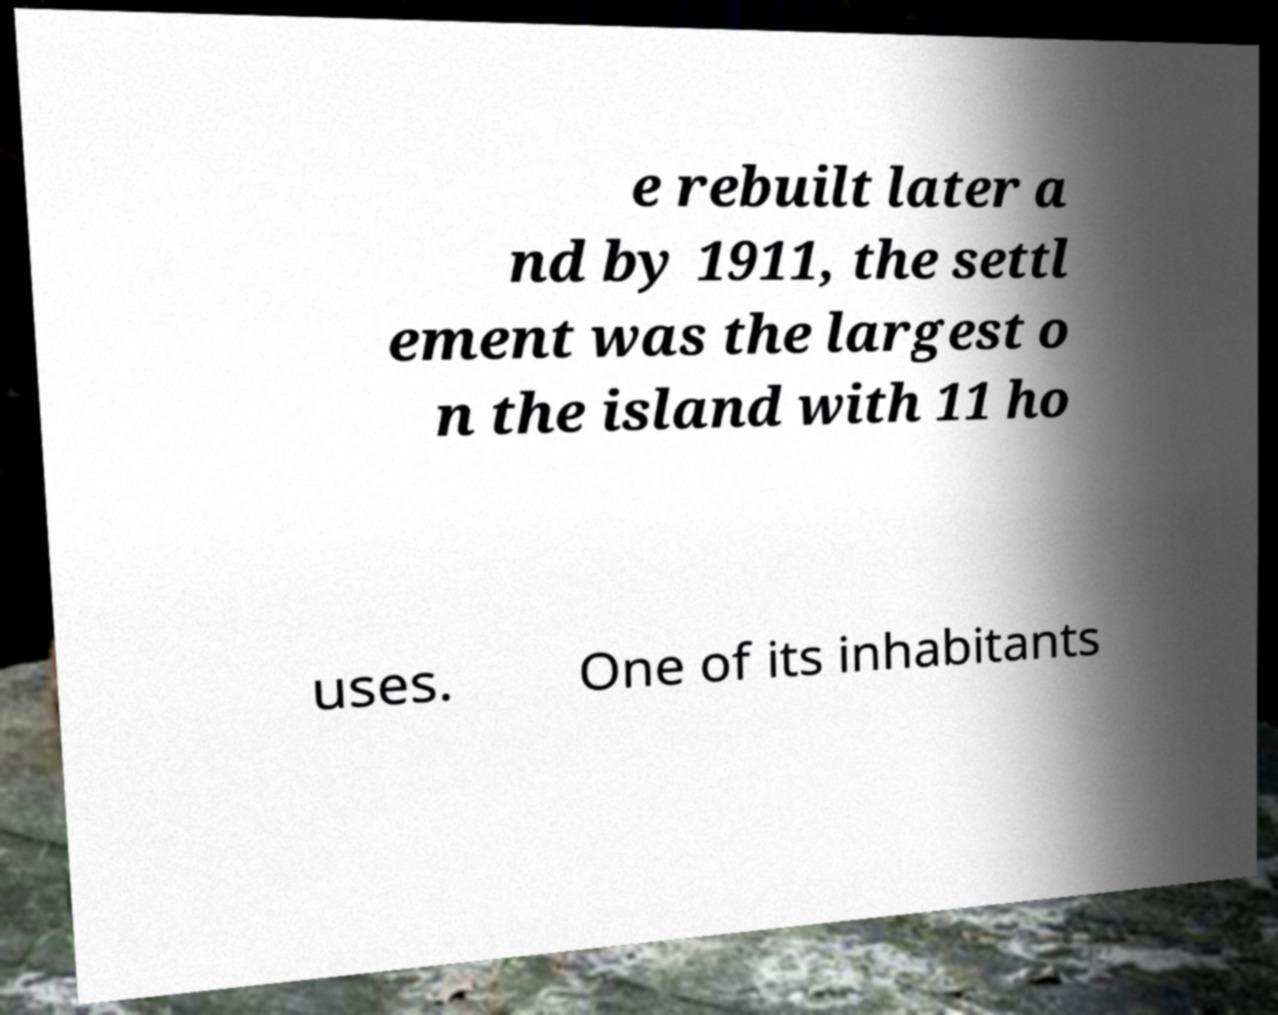Please read and relay the text visible in this image. What does it say? e rebuilt later a nd by 1911, the settl ement was the largest o n the island with 11 ho uses. One of its inhabitants 